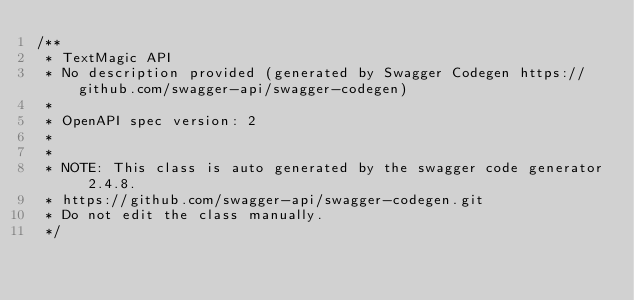Convert code to text. <code><loc_0><loc_0><loc_500><loc_500><_C++_>/**
 * TextMagic API
 * No description provided (generated by Swagger Codegen https://github.com/swagger-api/swagger-codegen)
 *
 * OpenAPI spec version: 2
 * 
 *
 * NOTE: This class is auto generated by the swagger code generator 2.4.8.
 * https://github.com/swagger-api/swagger-codegen.git
 * Do not edit the class manually.
 */


</code> 